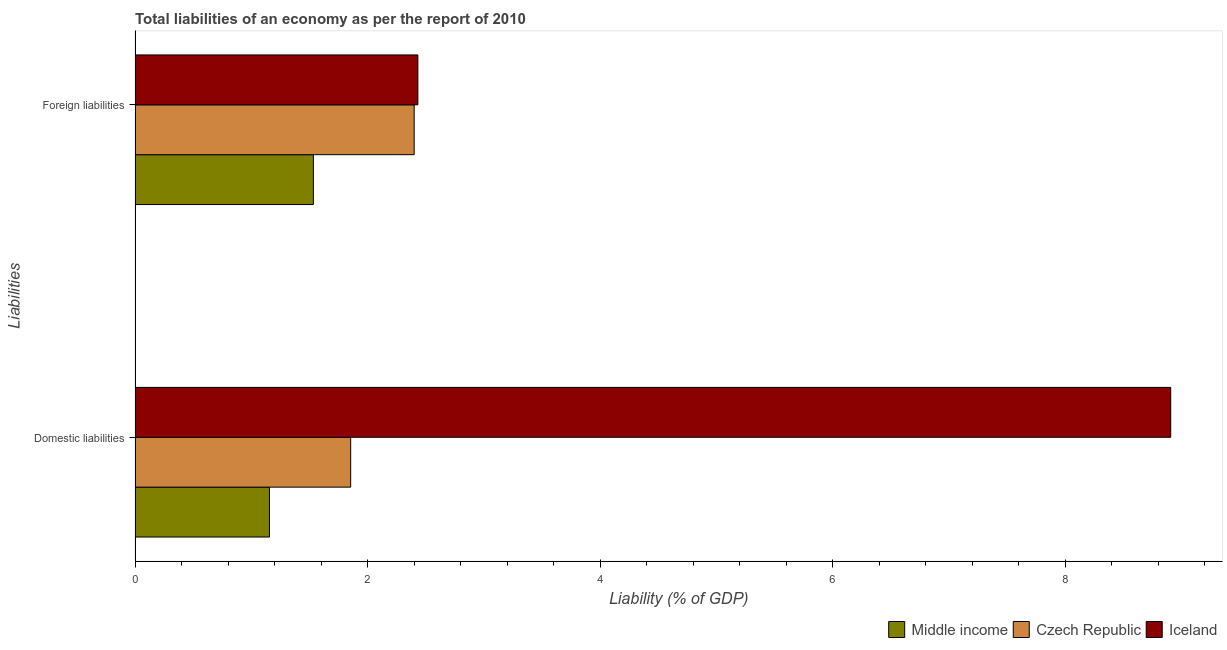How many bars are there on the 2nd tick from the bottom?
Offer a very short reply. 3. What is the label of the 2nd group of bars from the top?
Provide a succinct answer. Domestic liabilities. What is the incurrence of foreign liabilities in Czech Republic?
Your answer should be compact. 2.4. Across all countries, what is the maximum incurrence of domestic liabilities?
Ensure brevity in your answer.  8.91. Across all countries, what is the minimum incurrence of foreign liabilities?
Offer a very short reply. 1.53. In which country was the incurrence of domestic liabilities maximum?
Offer a terse response. Iceland. In which country was the incurrence of domestic liabilities minimum?
Your answer should be compact. Middle income. What is the total incurrence of foreign liabilities in the graph?
Make the answer very short. 6.37. What is the difference between the incurrence of domestic liabilities in Middle income and that in Iceland?
Your answer should be very brief. -7.75. What is the difference between the incurrence of foreign liabilities in Middle income and the incurrence of domestic liabilities in Czech Republic?
Provide a succinct answer. -0.32. What is the average incurrence of foreign liabilities per country?
Your response must be concise. 2.12. What is the difference between the incurrence of foreign liabilities and incurrence of domestic liabilities in Middle income?
Offer a very short reply. 0.38. What is the ratio of the incurrence of foreign liabilities in Iceland to that in Czech Republic?
Provide a short and direct response. 1.01. Is the incurrence of foreign liabilities in Iceland less than that in Czech Republic?
Give a very brief answer. No. What does the 2nd bar from the top in Domestic liabilities represents?
Give a very brief answer. Czech Republic. What does the 3rd bar from the bottom in Domestic liabilities represents?
Make the answer very short. Iceland. Are all the bars in the graph horizontal?
Your answer should be very brief. Yes. What is the difference between two consecutive major ticks on the X-axis?
Your response must be concise. 2. Does the graph contain any zero values?
Your response must be concise. No. Does the graph contain grids?
Offer a very short reply. No. What is the title of the graph?
Give a very brief answer. Total liabilities of an economy as per the report of 2010. What is the label or title of the X-axis?
Provide a short and direct response. Liability (% of GDP). What is the label or title of the Y-axis?
Ensure brevity in your answer.  Liabilities. What is the Liability (% of GDP) in Middle income in Domestic liabilities?
Provide a succinct answer. 1.16. What is the Liability (% of GDP) in Czech Republic in Domestic liabilities?
Offer a very short reply. 1.85. What is the Liability (% of GDP) of Iceland in Domestic liabilities?
Provide a succinct answer. 8.91. What is the Liability (% of GDP) in Middle income in Foreign liabilities?
Provide a succinct answer. 1.53. What is the Liability (% of GDP) of Czech Republic in Foreign liabilities?
Offer a terse response. 2.4. What is the Liability (% of GDP) in Iceland in Foreign liabilities?
Your answer should be compact. 2.43. Across all Liabilities, what is the maximum Liability (% of GDP) in Middle income?
Your response must be concise. 1.53. Across all Liabilities, what is the maximum Liability (% of GDP) in Czech Republic?
Provide a succinct answer. 2.4. Across all Liabilities, what is the maximum Liability (% of GDP) of Iceland?
Offer a terse response. 8.91. Across all Liabilities, what is the minimum Liability (% of GDP) in Middle income?
Make the answer very short. 1.16. Across all Liabilities, what is the minimum Liability (% of GDP) of Czech Republic?
Offer a terse response. 1.85. Across all Liabilities, what is the minimum Liability (% of GDP) in Iceland?
Make the answer very short. 2.43. What is the total Liability (% of GDP) of Middle income in the graph?
Your response must be concise. 2.69. What is the total Liability (% of GDP) of Czech Republic in the graph?
Your answer should be very brief. 4.26. What is the total Liability (% of GDP) in Iceland in the graph?
Keep it short and to the point. 11.34. What is the difference between the Liability (% of GDP) of Middle income in Domestic liabilities and that in Foreign liabilities?
Provide a short and direct response. -0.38. What is the difference between the Liability (% of GDP) of Czech Republic in Domestic liabilities and that in Foreign liabilities?
Give a very brief answer. -0.55. What is the difference between the Liability (% of GDP) of Iceland in Domestic liabilities and that in Foreign liabilities?
Keep it short and to the point. 6.48. What is the difference between the Liability (% of GDP) of Middle income in Domestic liabilities and the Liability (% of GDP) of Czech Republic in Foreign liabilities?
Your answer should be very brief. -1.24. What is the difference between the Liability (% of GDP) in Middle income in Domestic liabilities and the Liability (% of GDP) in Iceland in Foreign liabilities?
Ensure brevity in your answer.  -1.28. What is the difference between the Liability (% of GDP) of Czech Republic in Domestic liabilities and the Liability (% of GDP) of Iceland in Foreign liabilities?
Your answer should be very brief. -0.58. What is the average Liability (% of GDP) in Middle income per Liabilities?
Your response must be concise. 1.35. What is the average Liability (% of GDP) in Czech Republic per Liabilities?
Make the answer very short. 2.13. What is the average Liability (% of GDP) of Iceland per Liabilities?
Make the answer very short. 5.67. What is the difference between the Liability (% of GDP) in Middle income and Liability (% of GDP) in Czech Republic in Domestic liabilities?
Provide a succinct answer. -0.7. What is the difference between the Liability (% of GDP) in Middle income and Liability (% of GDP) in Iceland in Domestic liabilities?
Your response must be concise. -7.75. What is the difference between the Liability (% of GDP) in Czech Republic and Liability (% of GDP) in Iceland in Domestic liabilities?
Offer a very short reply. -7.05. What is the difference between the Liability (% of GDP) in Middle income and Liability (% of GDP) in Czech Republic in Foreign liabilities?
Your answer should be compact. -0.87. What is the difference between the Liability (% of GDP) in Middle income and Liability (% of GDP) in Iceland in Foreign liabilities?
Your response must be concise. -0.9. What is the difference between the Liability (% of GDP) of Czech Republic and Liability (% of GDP) of Iceland in Foreign liabilities?
Provide a succinct answer. -0.03. What is the ratio of the Liability (% of GDP) of Middle income in Domestic liabilities to that in Foreign liabilities?
Your answer should be compact. 0.75. What is the ratio of the Liability (% of GDP) of Czech Republic in Domestic liabilities to that in Foreign liabilities?
Your response must be concise. 0.77. What is the ratio of the Liability (% of GDP) in Iceland in Domestic liabilities to that in Foreign liabilities?
Offer a terse response. 3.66. What is the difference between the highest and the second highest Liability (% of GDP) of Middle income?
Give a very brief answer. 0.38. What is the difference between the highest and the second highest Liability (% of GDP) of Czech Republic?
Provide a short and direct response. 0.55. What is the difference between the highest and the second highest Liability (% of GDP) in Iceland?
Make the answer very short. 6.48. What is the difference between the highest and the lowest Liability (% of GDP) of Middle income?
Provide a succinct answer. 0.38. What is the difference between the highest and the lowest Liability (% of GDP) in Czech Republic?
Keep it short and to the point. 0.55. What is the difference between the highest and the lowest Liability (% of GDP) in Iceland?
Provide a short and direct response. 6.48. 